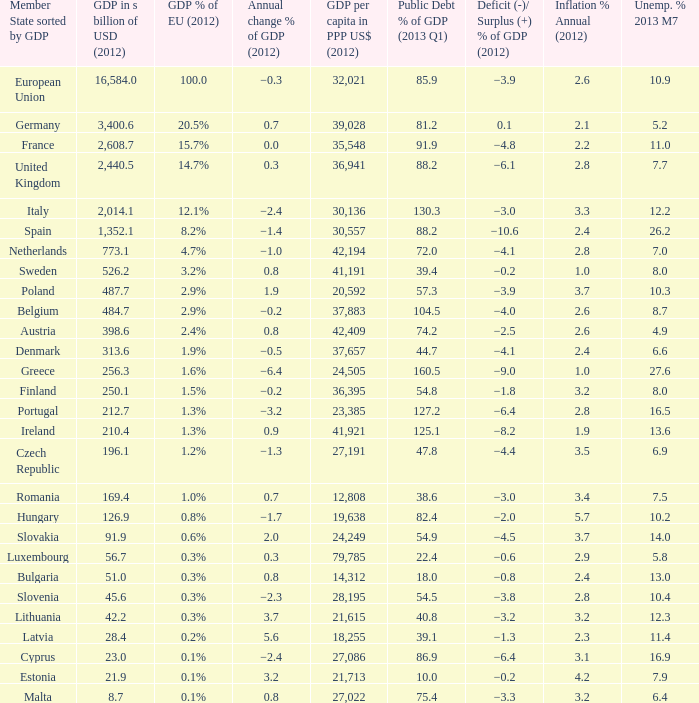What is the deficit/surplus % of the 2012 GDP of the country with a GDP in billions of USD in 2012 less than 1,352.1, a GDP per capita in PPP US dollars in 2012 greater than 21,615, public debt % of GDP in the 2013 Q1 less than 75.4, and an inflation % annual in 2012 of 2.9? −0.6. 